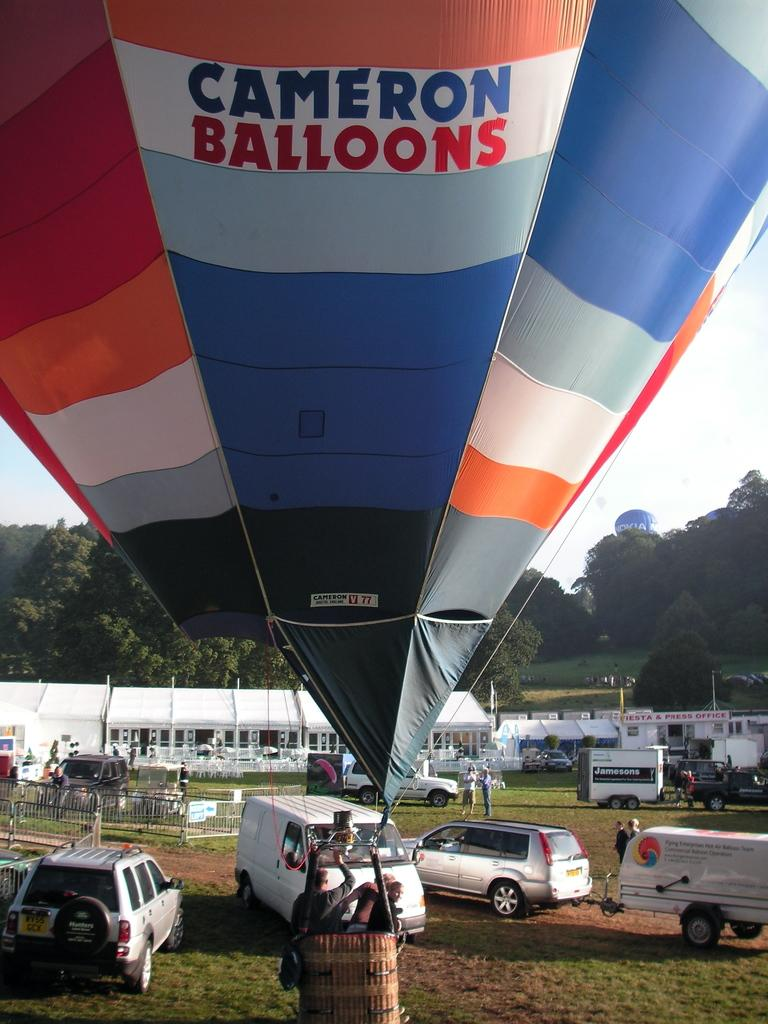<image>
Provide a brief description of the given image. A big floating balloon with the words Cameron Balloons wrote on it 